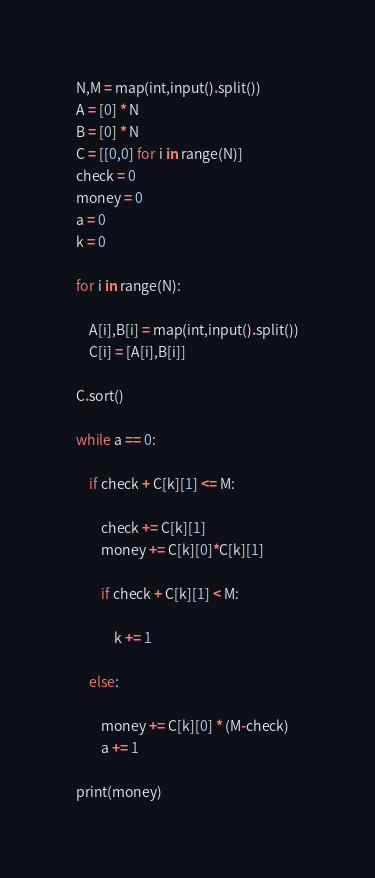Convert code to text. <code><loc_0><loc_0><loc_500><loc_500><_Python_>N,M = map(int,input().split())
A = [0] * N
B = [0] * N
C = [[0,0] for i in range(N)]
check = 0
money = 0
a = 0
k = 0

for i in range(N):

    A[i],B[i] = map(int,input().split())
    C[i] = [A[i],B[i]]

C.sort()

while a == 0:

    if check + C[k][1] <= M:

        check += C[k][1]
        money += C[k][0]*C[k][1]

        if check + C[k][1] < M:

            k += 1

    else:

        money += C[k][0] * (M-check)
        a += 1

print(money)</code> 